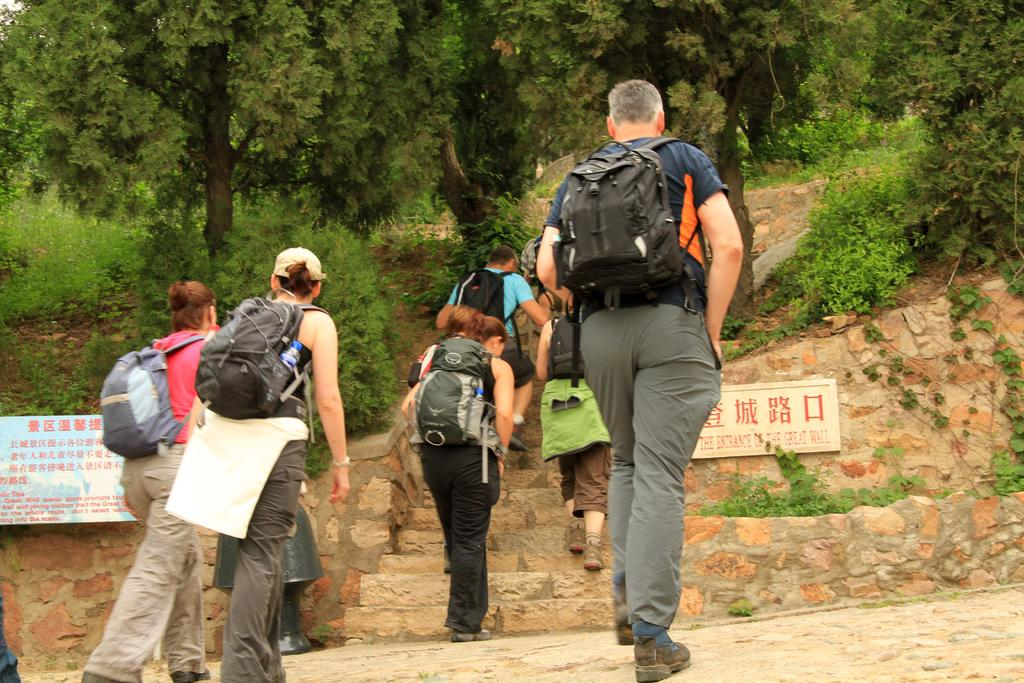How many persons are in the image? There are persons in the image, but the exact number is not specified. What are the persons wearing in the image? The persons are wearing bags in the image. What else can be seen in the image besides the persons? There are boards and plants visible in the image. What is visible in the background of the image? There are trees in the background of the image. What type of cord is being used to provide power to the plants in the image? There is no cord or power source visible in the image; the plants are not being powered. What type of pleasure can be seen on the faces of the persons in the image? The faces of the persons are not visible in the image, so their expressions and any associated pleasure cannot be determined. 